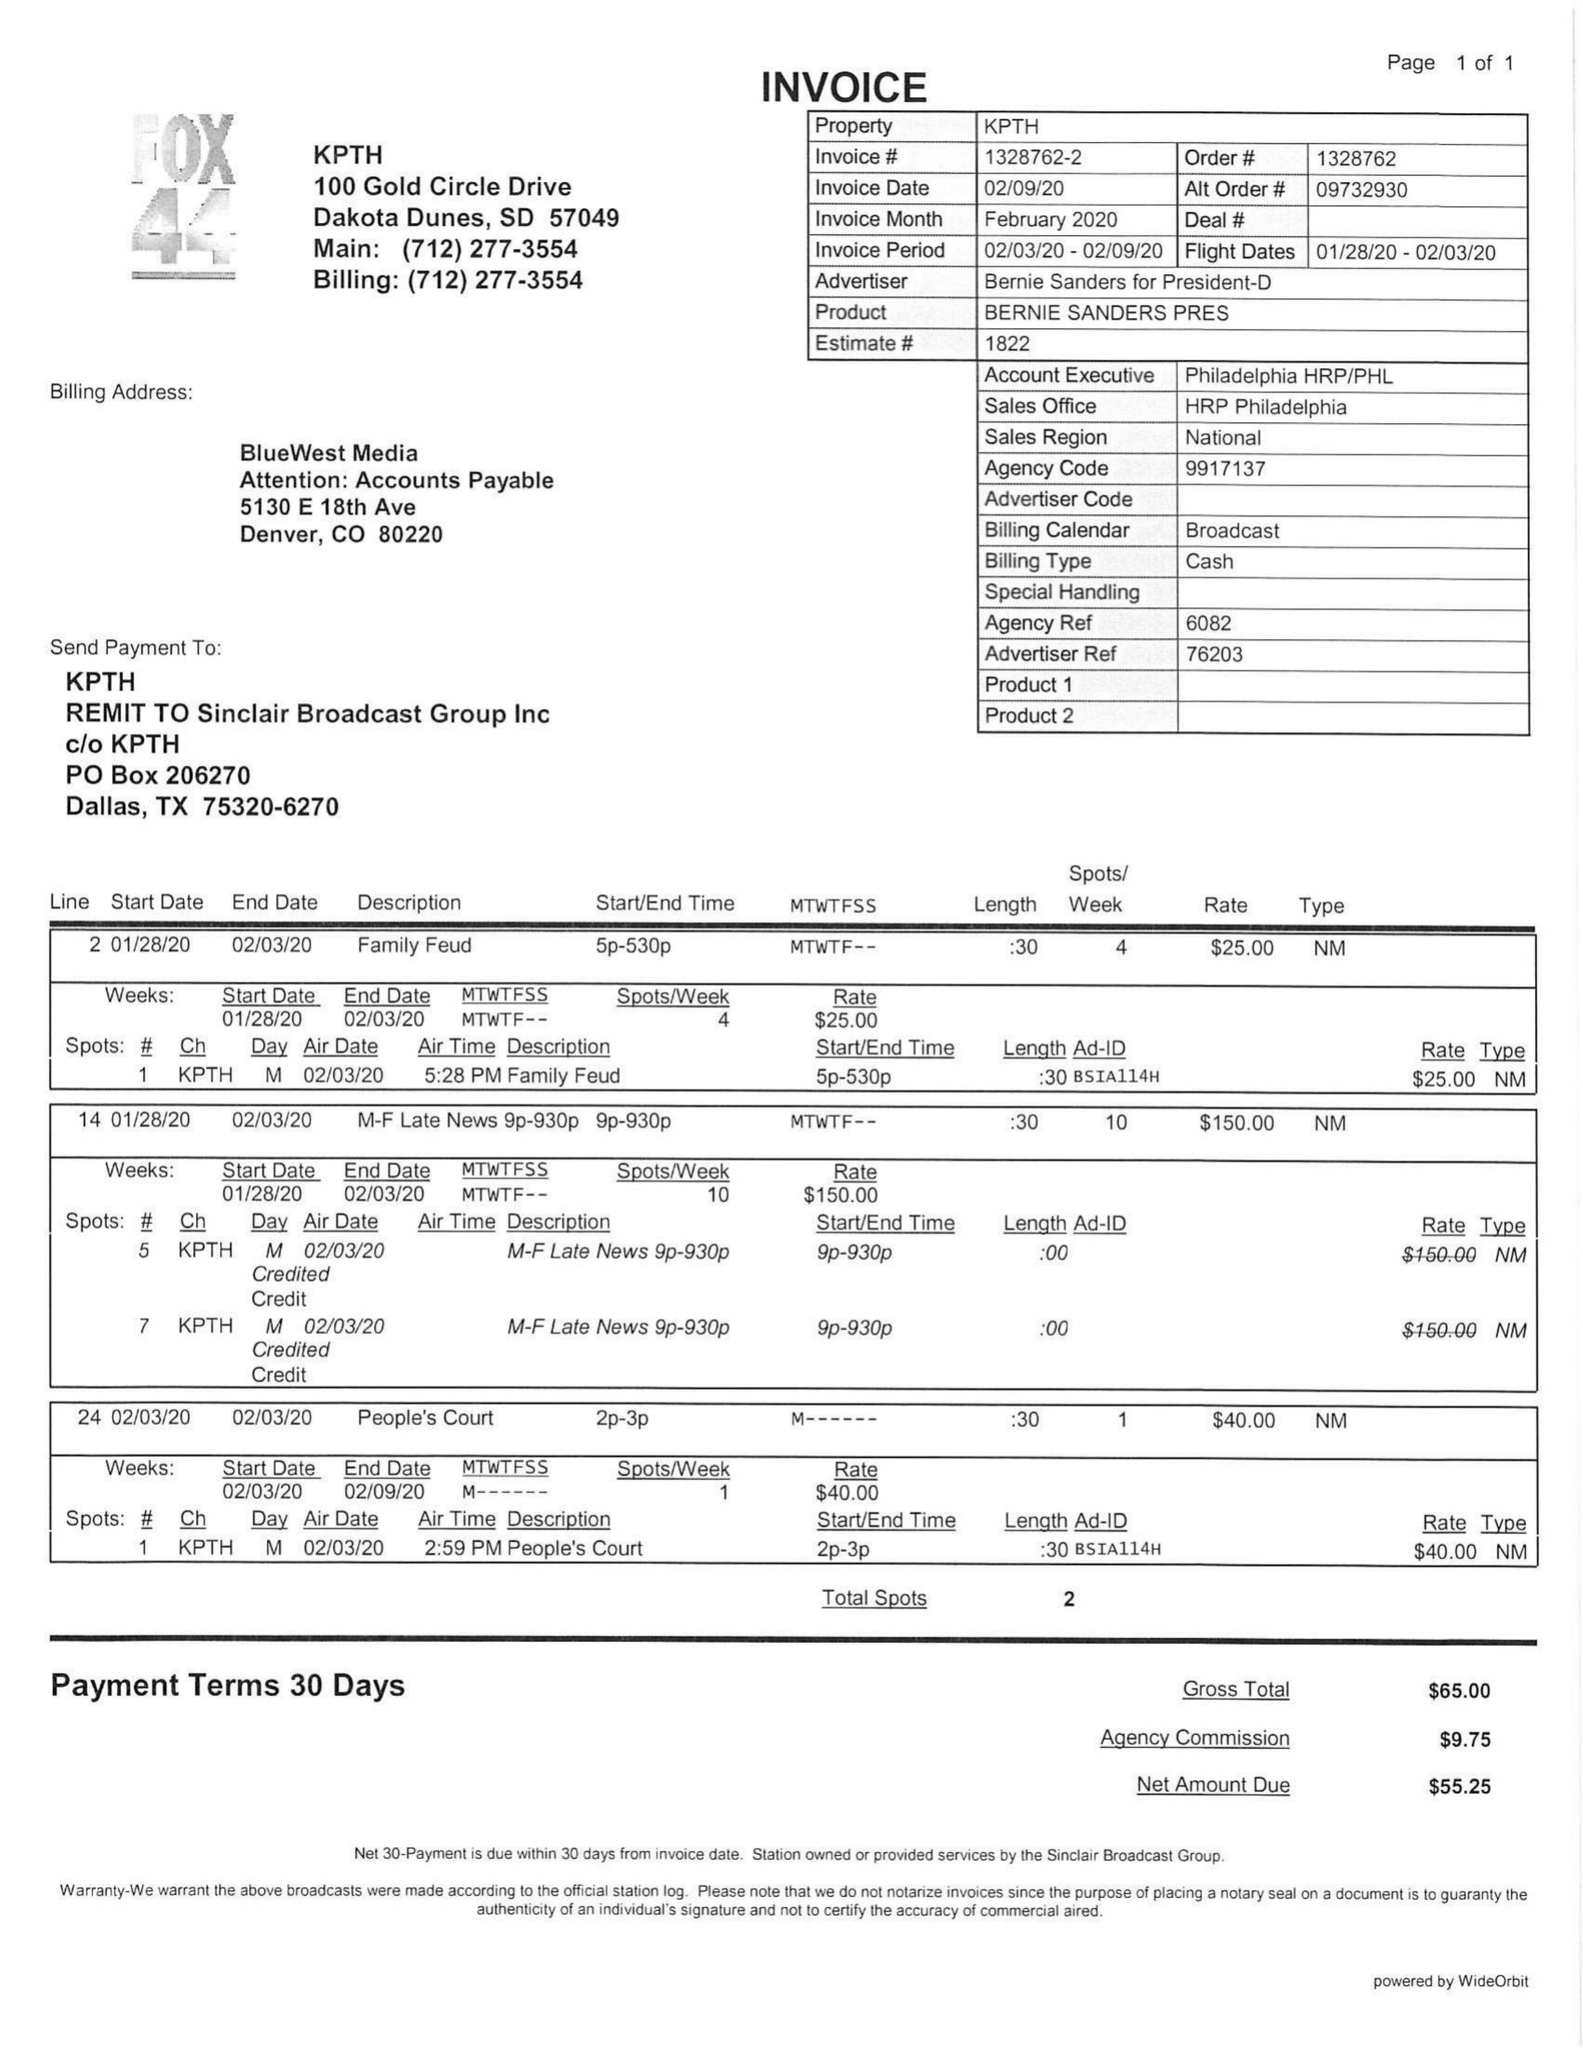What is the value for the gross_amount?
Answer the question using a single word or phrase. 65.00 